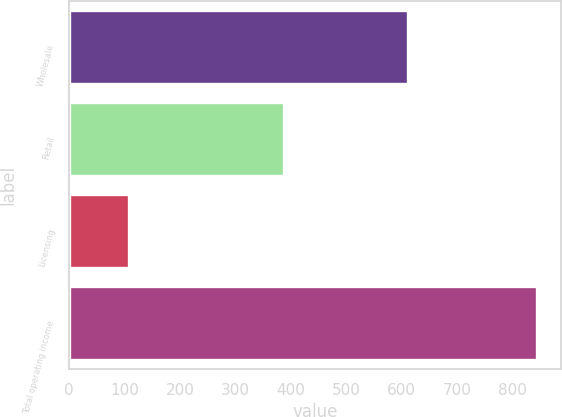<chart> <loc_0><loc_0><loc_500><loc_500><bar_chart><fcel>Wholesale<fcel>Retail<fcel>Licensing<fcel>Total operating income<nl><fcel>612.3<fcel>387.8<fcel>108.3<fcel>845.1<nl></chart> 